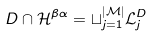Convert formula to latex. <formula><loc_0><loc_0><loc_500><loc_500>D \cap { \mathcal { H } } ^ { \beta \alpha } = \sqcup _ { j = 1 } ^ { | { \mathcal { M } } | } { \mathcal { L } } _ { j } ^ { D }</formula> 